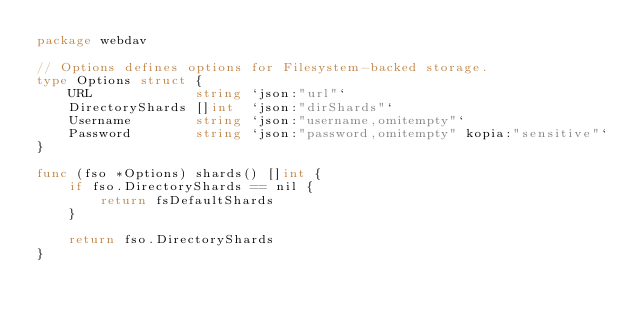Convert code to text. <code><loc_0><loc_0><loc_500><loc_500><_Go_>package webdav

// Options defines options for Filesystem-backed storage.
type Options struct {
	URL             string `json:"url"`
	DirectoryShards []int  `json:"dirShards"`
	Username        string `json:"username,omitempty"`
	Password        string `json:"password,omitempty" kopia:"sensitive"`
}

func (fso *Options) shards() []int {
	if fso.DirectoryShards == nil {
		return fsDefaultShards
	}

	return fso.DirectoryShards
}
</code> 